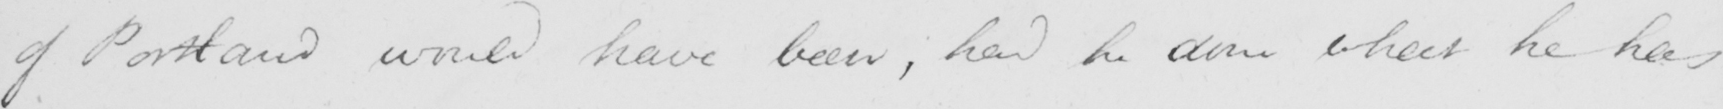What is written in this line of handwriting? of Portland would have been , had he done what he has 